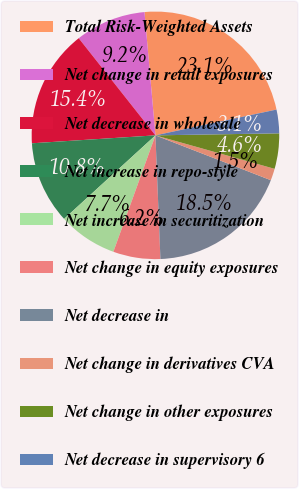Convert chart to OTSL. <chart><loc_0><loc_0><loc_500><loc_500><pie_chart><fcel>Total Risk-Weighted Assets<fcel>Net change in retail exposures<fcel>Net decrease in wholesale<fcel>Net increase in repo-style<fcel>Net increase in securitization<fcel>Net change in equity exposures<fcel>Net decrease in<fcel>Net change in derivatives CVA<fcel>Net change in other exposures<fcel>Net decrease in supervisory 6<nl><fcel>23.07%<fcel>9.23%<fcel>15.38%<fcel>10.77%<fcel>7.69%<fcel>6.16%<fcel>18.46%<fcel>1.54%<fcel>4.62%<fcel>3.08%<nl></chart> 